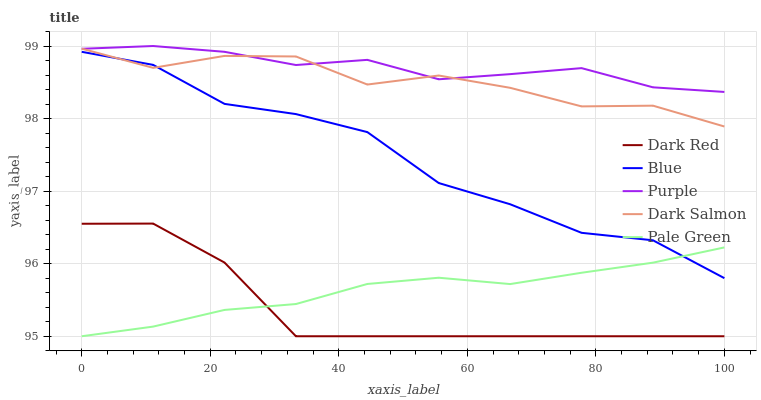Does Dark Red have the minimum area under the curve?
Answer yes or no. Yes. Does Purple have the maximum area under the curve?
Answer yes or no. Yes. Does Pale Green have the minimum area under the curve?
Answer yes or no. No. Does Pale Green have the maximum area under the curve?
Answer yes or no. No. Is Pale Green the smoothest?
Answer yes or no. Yes. Is Blue the roughest?
Answer yes or no. Yes. Is Dark Red the smoothest?
Answer yes or no. No. Is Dark Red the roughest?
Answer yes or no. No. Does Dark Red have the lowest value?
Answer yes or no. Yes. Does Dark Salmon have the lowest value?
Answer yes or no. No. Does Purple have the highest value?
Answer yes or no. Yes. Does Dark Red have the highest value?
Answer yes or no. No. Is Dark Red less than Purple?
Answer yes or no. Yes. Is Dark Salmon greater than Pale Green?
Answer yes or no. Yes. Does Blue intersect Dark Salmon?
Answer yes or no. Yes. Is Blue less than Dark Salmon?
Answer yes or no. No. Is Blue greater than Dark Salmon?
Answer yes or no. No. Does Dark Red intersect Purple?
Answer yes or no. No. 